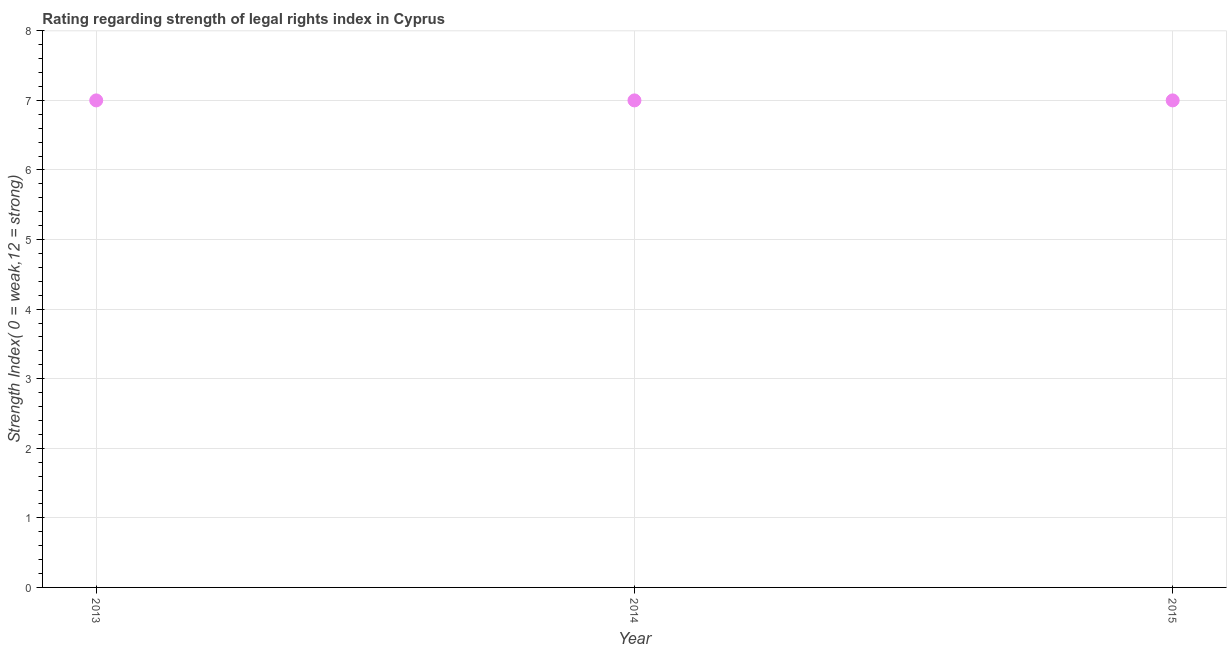What is the strength of legal rights index in 2014?
Make the answer very short. 7. Across all years, what is the maximum strength of legal rights index?
Ensure brevity in your answer.  7. Across all years, what is the minimum strength of legal rights index?
Your answer should be very brief. 7. In which year was the strength of legal rights index maximum?
Make the answer very short. 2013. What is the sum of the strength of legal rights index?
Ensure brevity in your answer.  21. What is the average strength of legal rights index per year?
Make the answer very short. 7. In how many years, is the strength of legal rights index greater than 2 ?
Offer a very short reply. 3. What is the ratio of the strength of legal rights index in 2014 to that in 2015?
Your answer should be compact. 1. Is the difference between the strength of legal rights index in 2013 and 2015 greater than the difference between any two years?
Provide a succinct answer. Yes. What is the difference between the highest and the lowest strength of legal rights index?
Your answer should be compact. 0. Does the strength of legal rights index monotonically increase over the years?
Your answer should be very brief. No. What is the difference between two consecutive major ticks on the Y-axis?
Your answer should be very brief. 1. Does the graph contain any zero values?
Provide a short and direct response. No. What is the title of the graph?
Offer a terse response. Rating regarding strength of legal rights index in Cyprus. What is the label or title of the X-axis?
Make the answer very short. Year. What is the label or title of the Y-axis?
Make the answer very short. Strength Index( 0 = weak,12 = strong). What is the Strength Index( 0 = weak,12 = strong) in 2013?
Your answer should be very brief. 7. What is the difference between the Strength Index( 0 = weak,12 = strong) in 2014 and 2015?
Your answer should be compact. 0. What is the ratio of the Strength Index( 0 = weak,12 = strong) in 2014 to that in 2015?
Give a very brief answer. 1. 